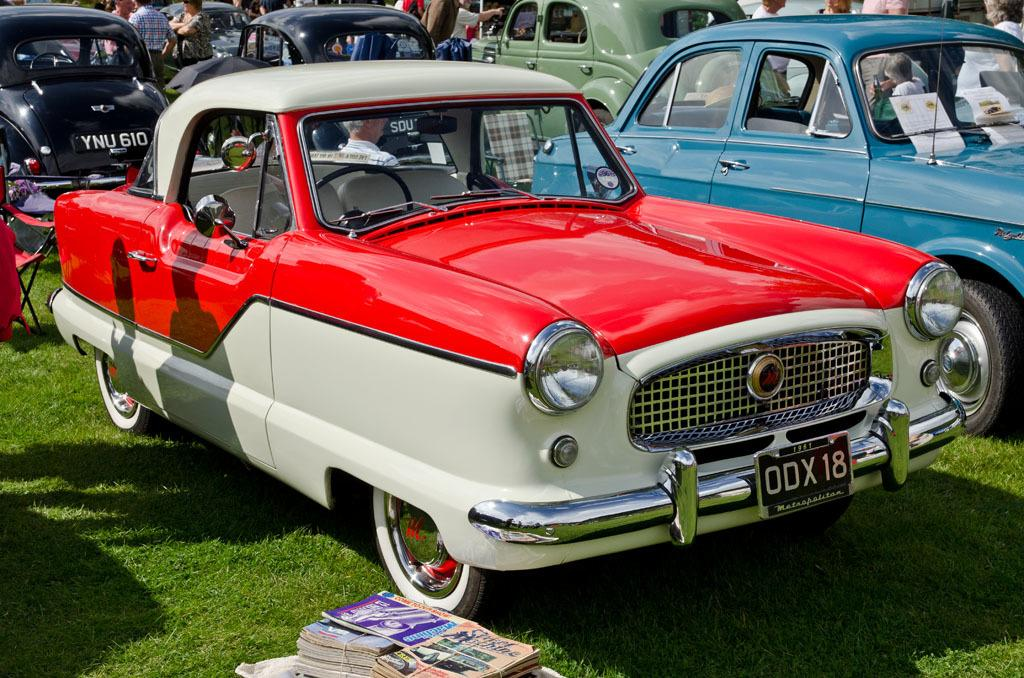What types of objects can be seen in the image? There are vehicles and people in the image. What is the ground covered with in the image? The ground is covered with grass in the image. Can you describe an object with seating in the image? There is a chair with some cloth in the image. What can be found at the bottom of the image? There are posters at the bottom of the image. How many bushes can be seen in the image? There are no bushes present in the image. Can you describe the airplane in the image? There is no airplane present in the image. 